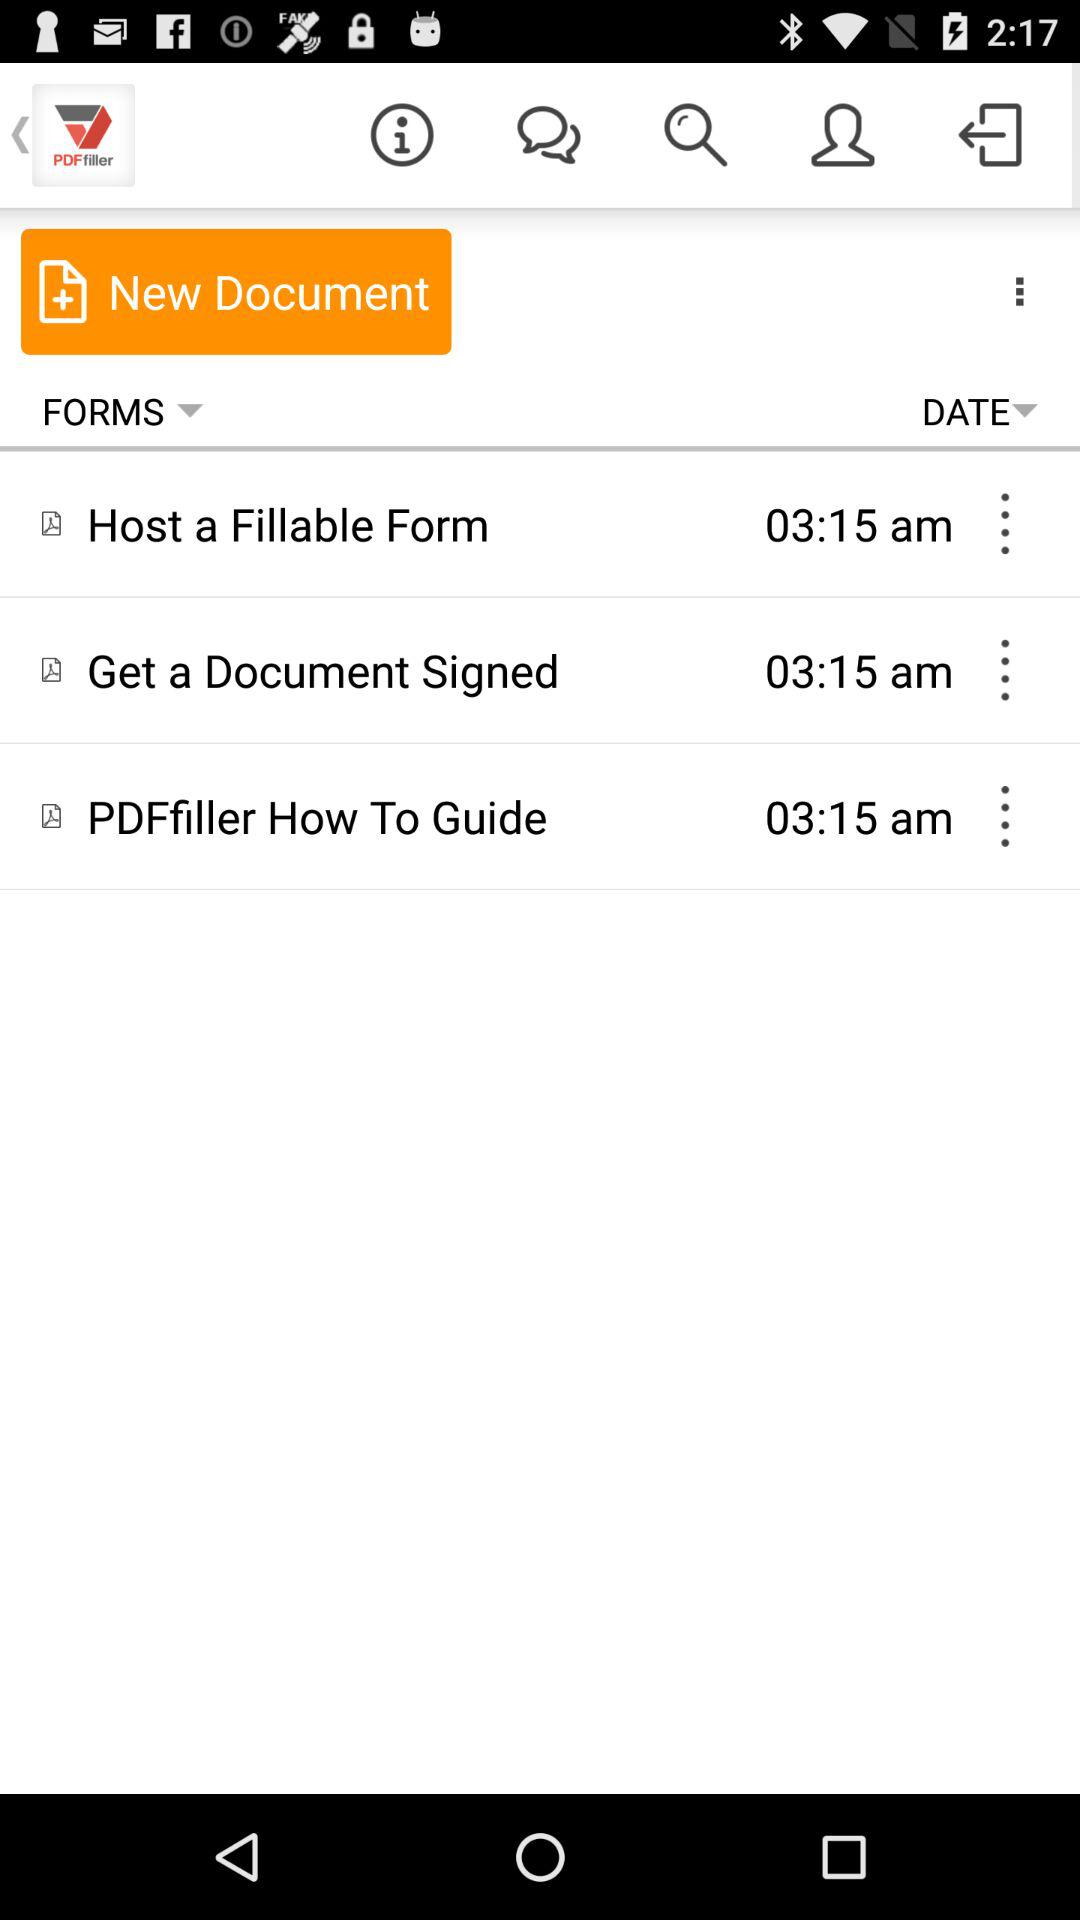What is the time of the "Host a Fillable Form"? The time is 3:15 am. 